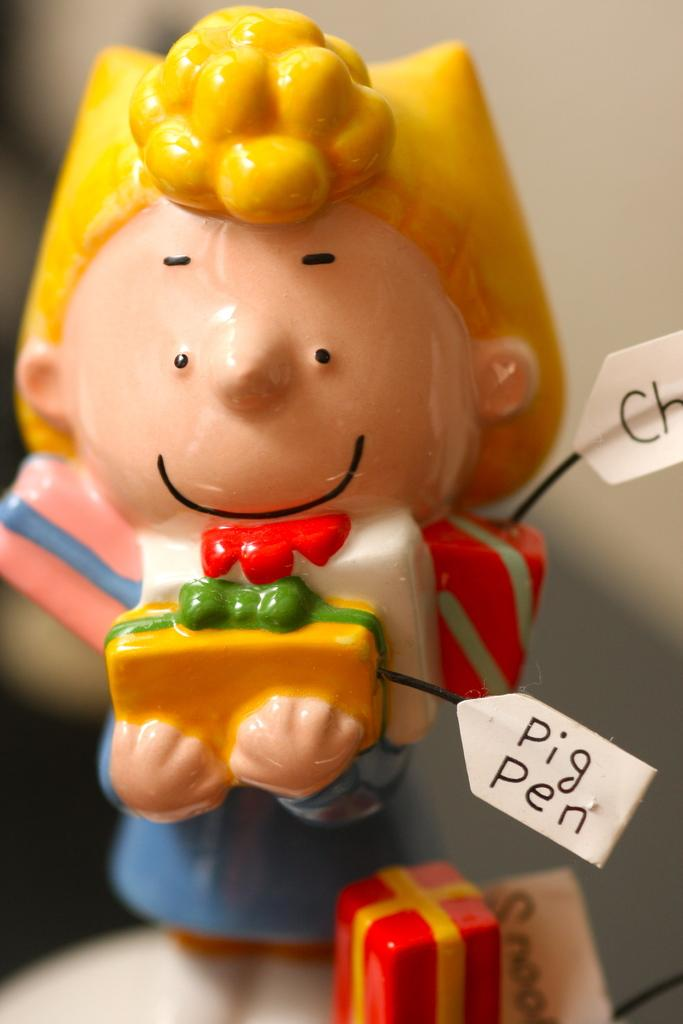What is the main object in the picture? There is a toy in the picture. Are there any words or letters visible in the picture? Yes, there is text visible in the picture. How would you describe the overall clarity of the image? The surroundings of the image are slightly blurred. What type of cream is being used by the duck in the image? There is no duck or cream present in the image; it features a toy and text. 